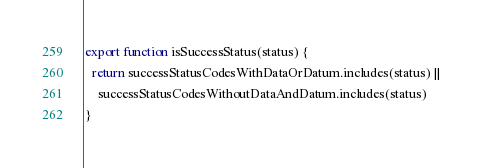Convert code to text. <code><loc_0><loc_0><loc_500><loc_500><_JavaScript_>
export function isSuccessStatus(status) {
  return successStatusCodesWithDataOrDatum.includes(status) ||
    successStatusCodesWithoutDataAndDatum.includes(status)
}
</code> 